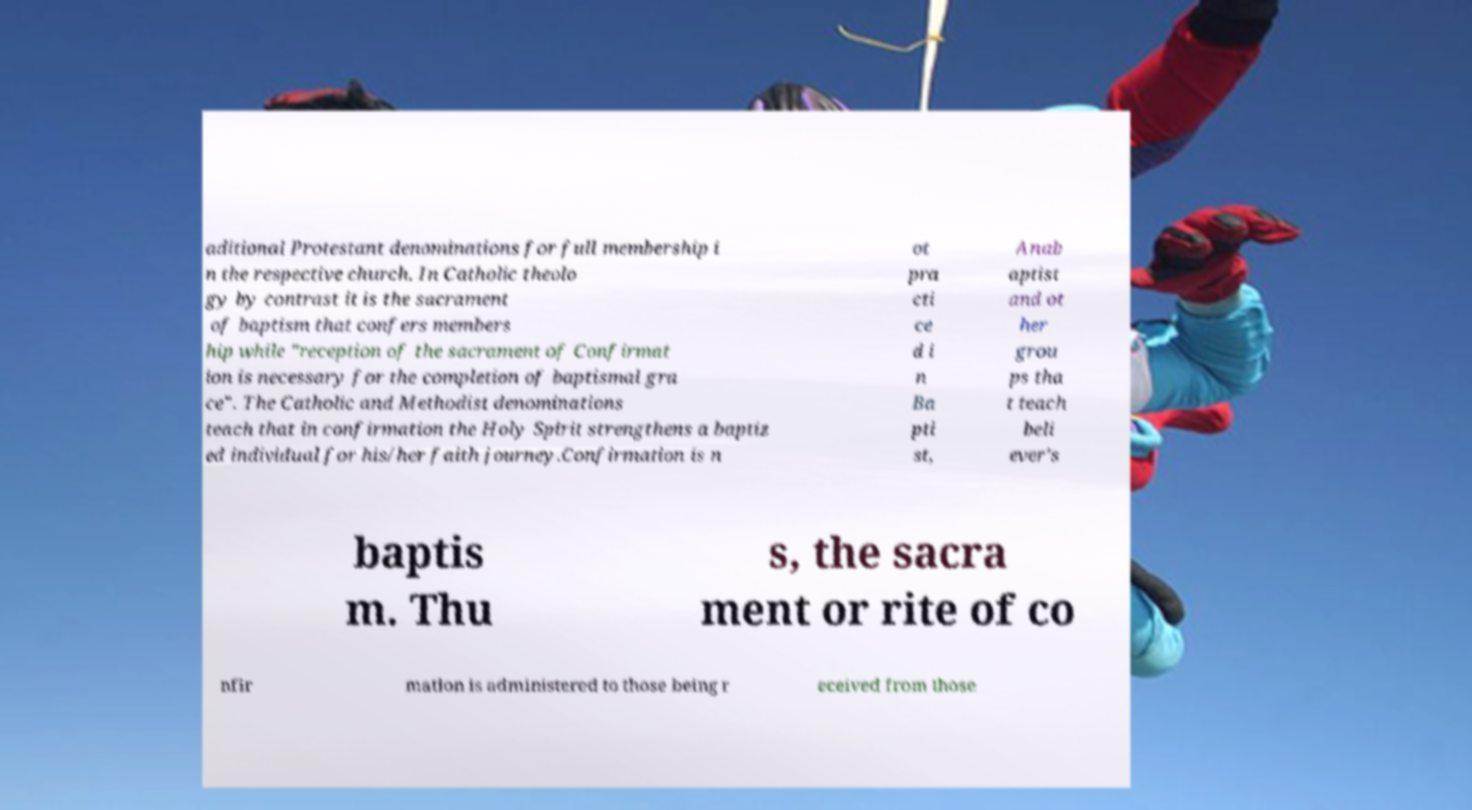There's text embedded in this image that I need extracted. Can you transcribe it verbatim? aditional Protestant denominations for full membership i n the respective church. In Catholic theolo gy by contrast it is the sacrament of baptism that confers members hip while "reception of the sacrament of Confirmat ion is necessary for the completion of baptismal gra ce". The Catholic and Methodist denominations teach that in confirmation the Holy Spirit strengthens a baptiz ed individual for his/her faith journey.Confirmation is n ot pra cti ce d i n Ba pti st, Anab aptist and ot her grou ps tha t teach beli ever's baptis m. Thu s, the sacra ment or rite of co nfir mation is administered to those being r eceived from those 